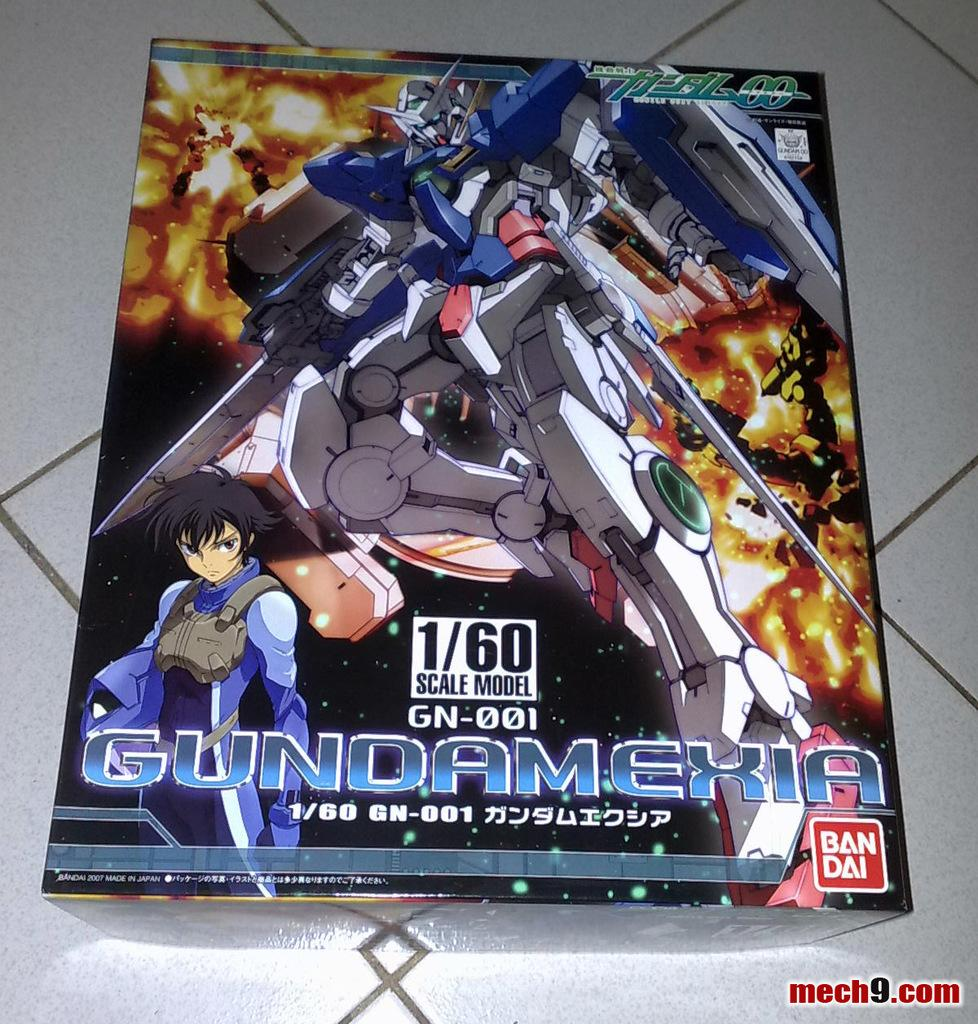Provide a one-sentence caption for the provided image. An image of a robot with Gubdamekia by Ban Dai with website mech9.com in the right corner. 